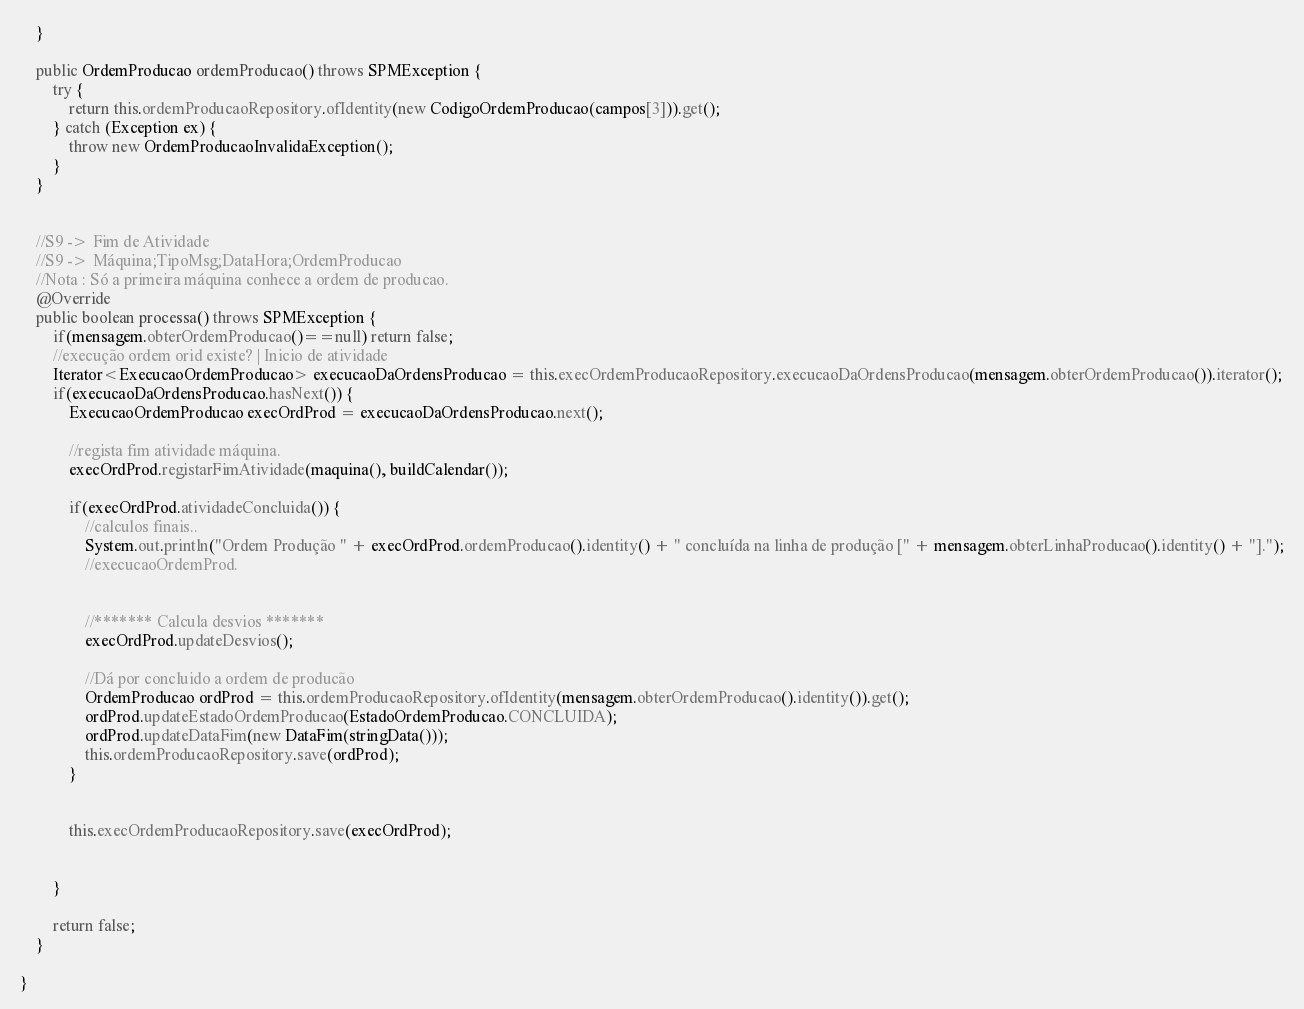<code> <loc_0><loc_0><loc_500><loc_500><_Java_>    }
    
    public OrdemProducao ordemProducao() throws SPMException {
        try {
            return this.ordemProducaoRepository.ofIdentity(new CodigoOrdemProducao(campos[3])).get();             
        } catch (Exception ex) {
            throw new OrdemProducaoInvalidaException();
        }
    }
    
    
    //S9 -> Fim de Atividade
    //S9 -> Máquina;TipoMsg;DataHora;OrdemProducao
    //Nota : Só a primeira máquina conhece a ordem de producao.
    @Override
    public boolean processa() throws SPMException {
        if(mensagem.obterOrdemProducao()==null) return false;
        //execução ordem orid existe? | Inicio de atividade
        Iterator<ExecucaoOrdemProducao> execucaoDaOrdensProducao = this.execOrdemProducaoRepository.execucaoDaOrdensProducao(mensagem.obterOrdemProducao()).iterator();
        if(execucaoDaOrdensProducao.hasNext()) {
            ExecucaoOrdemProducao execOrdProd = execucaoDaOrdensProducao.next();
            
            //regista fim atividade máquina.
            execOrdProd.registarFimAtividade(maquina(), buildCalendar());
            
            if(execOrdProd.atividadeConcluida()) {
                //calculos finais..
                System.out.println("Ordem Produção " + execOrdProd.ordemProducao().identity() + " concluída na linha de produção [" + mensagem.obterLinhaProducao().identity() + "].");
                //execucaoOrdemProd.
                
                
                //******* Calcula desvios *******
                execOrdProd.updateDesvios();
                
                //Dá por concluido a ordem de producão
                OrdemProducao ordProd = this.ordemProducaoRepository.ofIdentity(mensagem.obterOrdemProducao().identity()).get();
                ordProd.updateEstadoOrdemProducao(EstadoOrdemProducao.CONCLUIDA);
                ordProd.updateDataFim(new DataFim(stringData()));
                this.ordemProducaoRepository.save(ordProd);
            }
            
            
            this.execOrdemProducaoRepository.save(execOrdProd);
            
            
        }
        
        return false;
    }
    
}
</code> 